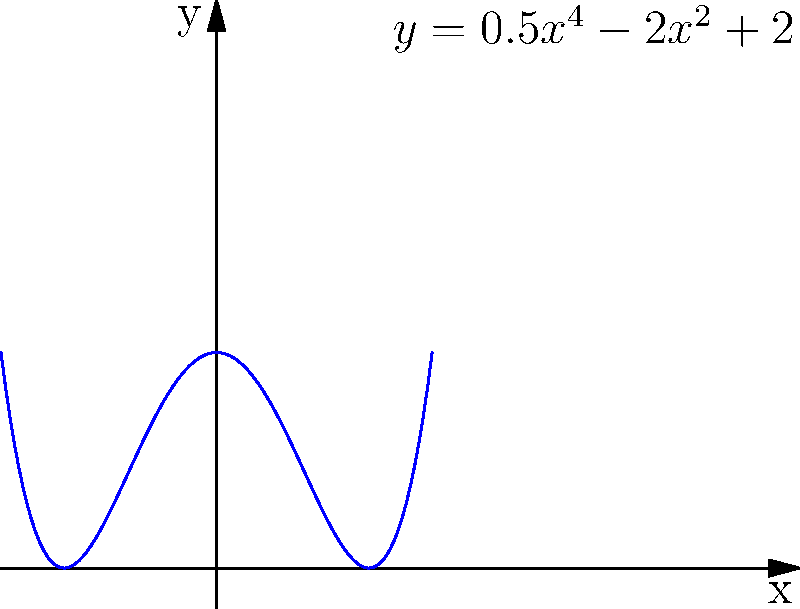The polynomial curve $y = 0.5x^4 - 2x^2 + 2$ represents the cross-sectional profile of an onion dome in an Eastern Orthodox church. What architectural feature does the local minimum at $x=0$ represent, and how many inflection points does this curve have? To answer this question, we need to analyze the given polynomial function:

1. Local minimum:
   The local minimum at $x=0$ represents the narrowest point of the onion dome, often called the "neck" or "waist" of the dome.

2. Inflection points:
   To find the inflection points, we need to calculate the second derivative and find where it equals zero.

   First derivative: $f'(x) = 2x^3 - 4x$
   Second derivative: $f''(x) = 6x^2 - 4$

   Set $f''(x) = 0$:
   $6x^2 - 4 = 0$
   $6x^2 = 4$
   $x^2 = \frac{2}{3}$
   $x = \pm \sqrt{\frac{2}{3}}$

   Therefore, there are two inflection points at $x = \pm \sqrt{\frac{2}{3}}$.

The architectural feature at $x=0$ is the neck of the dome, and the curve has 2 inflection points.
Answer: Neck; 2 inflection points 